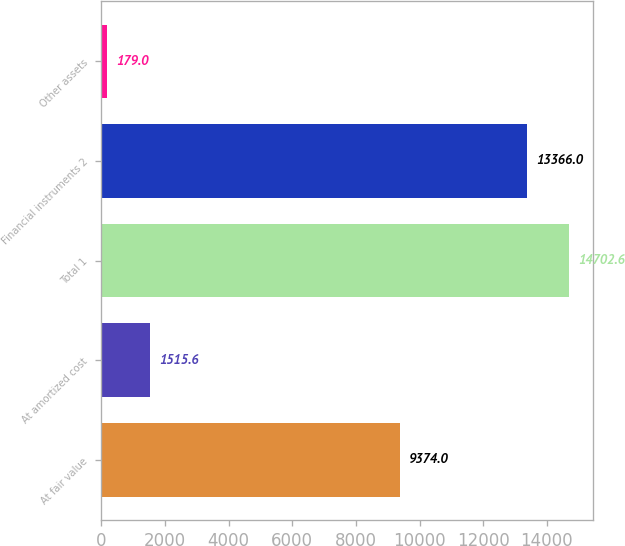<chart> <loc_0><loc_0><loc_500><loc_500><bar_chart><fcel>At fair value<fcel>At amortized cost<fcel>Total 1<fcel>Financial instruments 2<fcel>Other assets<nl><fcel>9374<fcel>1515.6<fcel>14702.6<fcel>13366<fcel>179<nl></chart> 